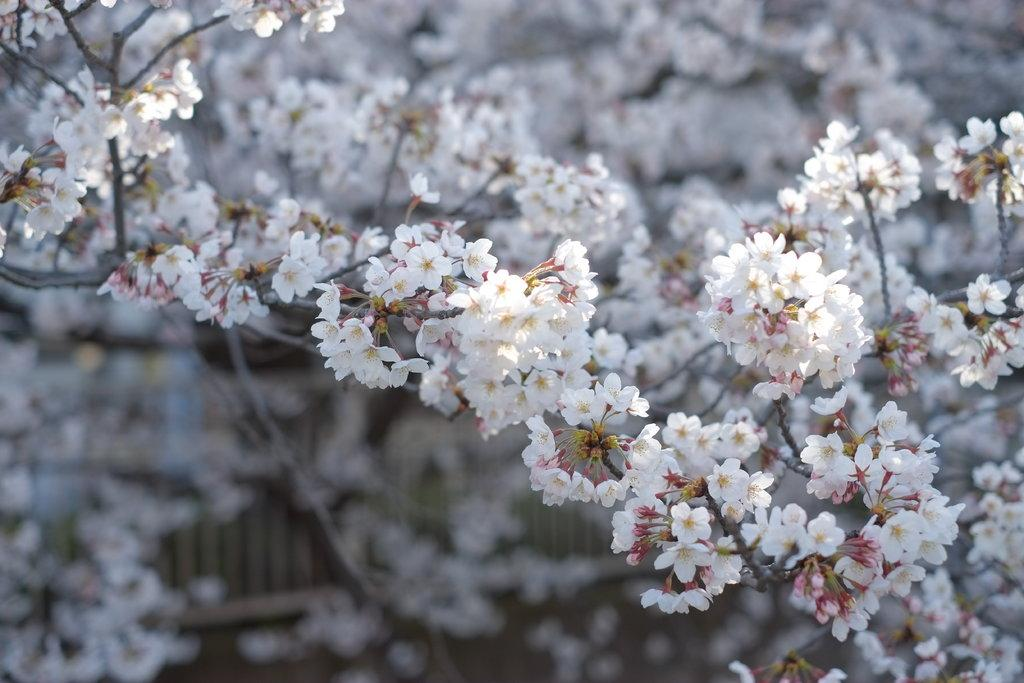What type of flowers can be seen on the tree in the image? There are white color flowers on the tree in the image. Where are the flowers located? The flowers are on a tree. What can be seen at the back of the image? There is a railing at the back of the image. What is visible at the bottom of the image? The ground is visible at the bottom of the image. Can you see a giraffe wearing a hat in the image? No, there is no giraffe or hat present in the image. 